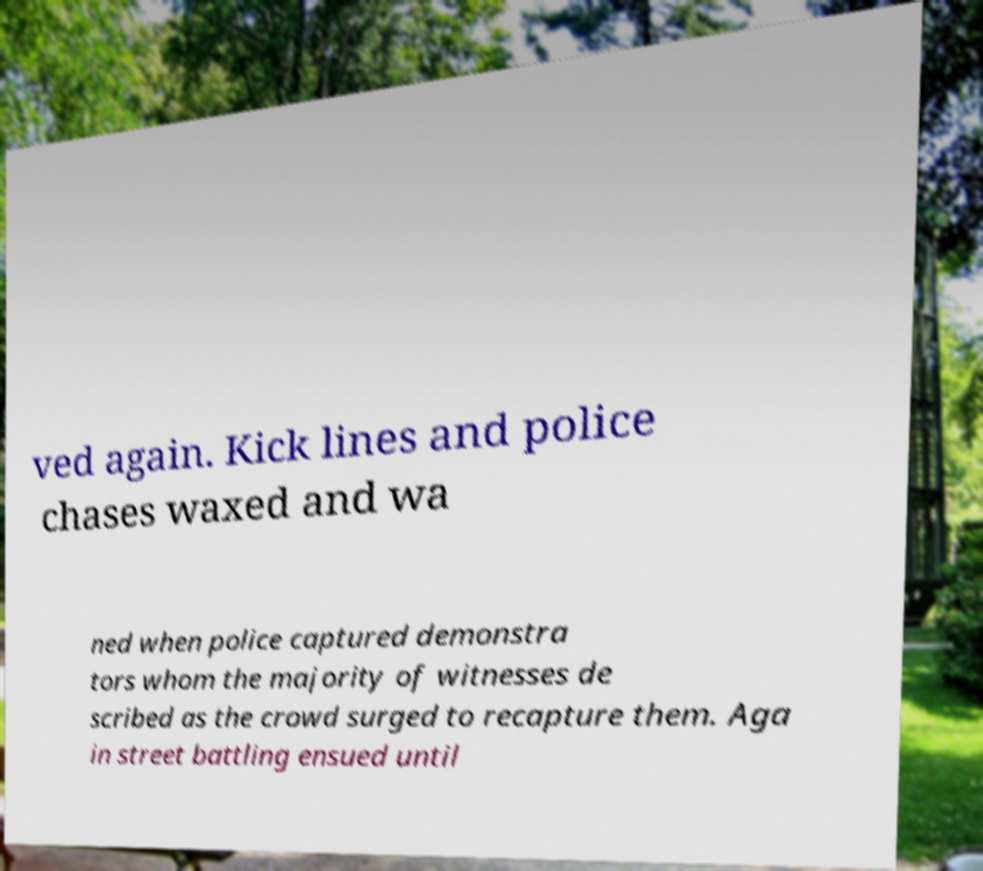I need the written content from this picture converted into text. Can you do that? ved again. Kick lines and police chases waxed and wa ned when police captured demonstra tors whom the majority of witnesses de scribed as the crowd surged to recapture them. Aga in street battling ensued until 